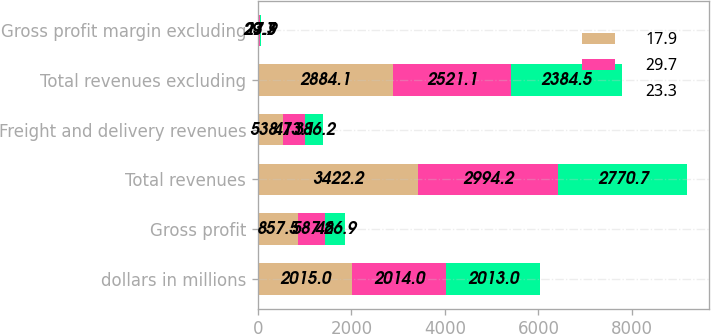Convert chart to OTSL. <chart><loc_0><loc_0><loc_500><loc_500><stacked_bar_chart><ecel><fcel>dollars in millions<fcel>Gross profit<fcel>Total revenues<fcel>Freight and delivery revenues<fcel>Total revenues excluding<fcel>Gross profit margin excluding<nl><fcel>17.9<fcel>2015<fcel>857.5<fcel>3422.2<fcel>538.1<fcel>2884.1<fcel>29.7<nl><fcel>29.7<fcel>2014<fcel>587.6<fcel>2994.2<fcel>473.1<fcel>2521.1<fcel>23.3<nl><fcel>23.3<fcel>2013<fcel>426.9<fcel>2770.7<fcel>386.2<fcel>2384.5<fcel>17.9<nl></chart> 